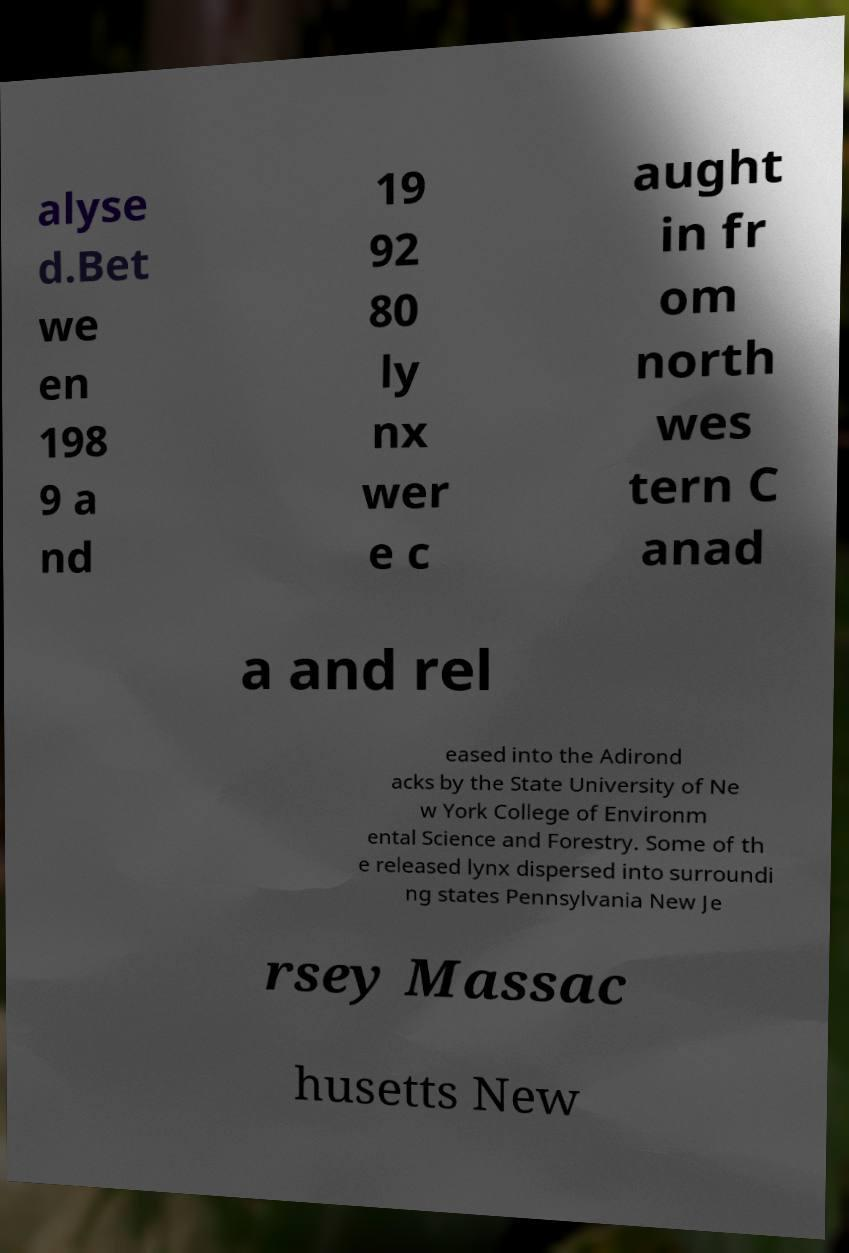What messages or text are displayed in this image? I need them in a readable, typed format. alyse d.Bet we en 198 9 a nd 19 92 80 ly nx wer e c aught in fr om north wes tern C anad a and rel eased into the Adirond acks by the State University of Ne w York College of Environm ental Science and Forestry. Some of th e released lynx dispersed into surroundi ng states Pennsylvania New Je rsey Massac husetts New 